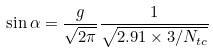<formula> <loc_0><loc_0><loc_500><loc_500>\sin \alpha = \frac { g } { \sqrt { 2 \pi } } \frac { 1 } { \sqrt { 2 . 9 1 \times 3 / N _ { t c } } }</formula> 